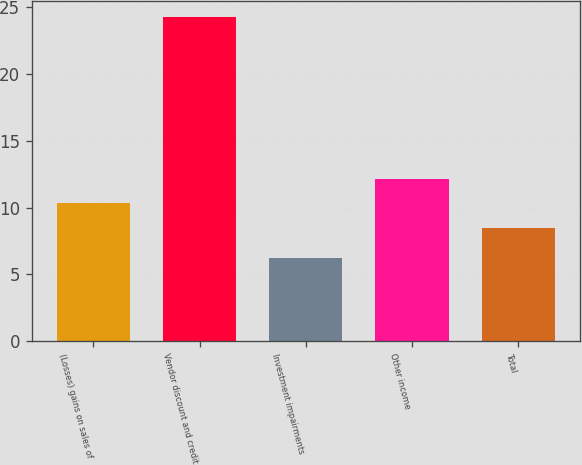<chart> <loc_0><loc_0><loc_500><loc_500><bar_chart><fcel>(Losses) gains on sales of<fcel>Vendor discount and credit<fcel>Investment impairments<fcel>Other income<fcel>Total<nl><fcel>10.31<fcel>24.3<fcel>6.2<fcel>12.12<fcel>8.5<nl></chart> 